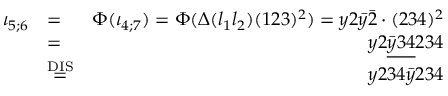Convert formula to latex. <formula><loc_0><loc_0><loc_500><loc_500>\begin{array} { r l r } { \iota _ { 5 ; 6 } } & { = } & { \Phi ( \iota _ { 4 ; 7 } ) = \Phi ( \Delta ( l _ { 1 } l _ { 2 } ) ( 1 2 3 ) ^ { 2 } ) = y 2 \bar { y } \bar { 2 } \cdot ( 2 3 4 ) ^ { 2 } } \\ & { = } & { y 2 \underline { { \bar { y } 3 4 } } 2 3 4 } \\ & { \stackrel { D I S } { = } } & { y 2 3 4 \bar { y } 2 3 4 } \end{array}</formula> 